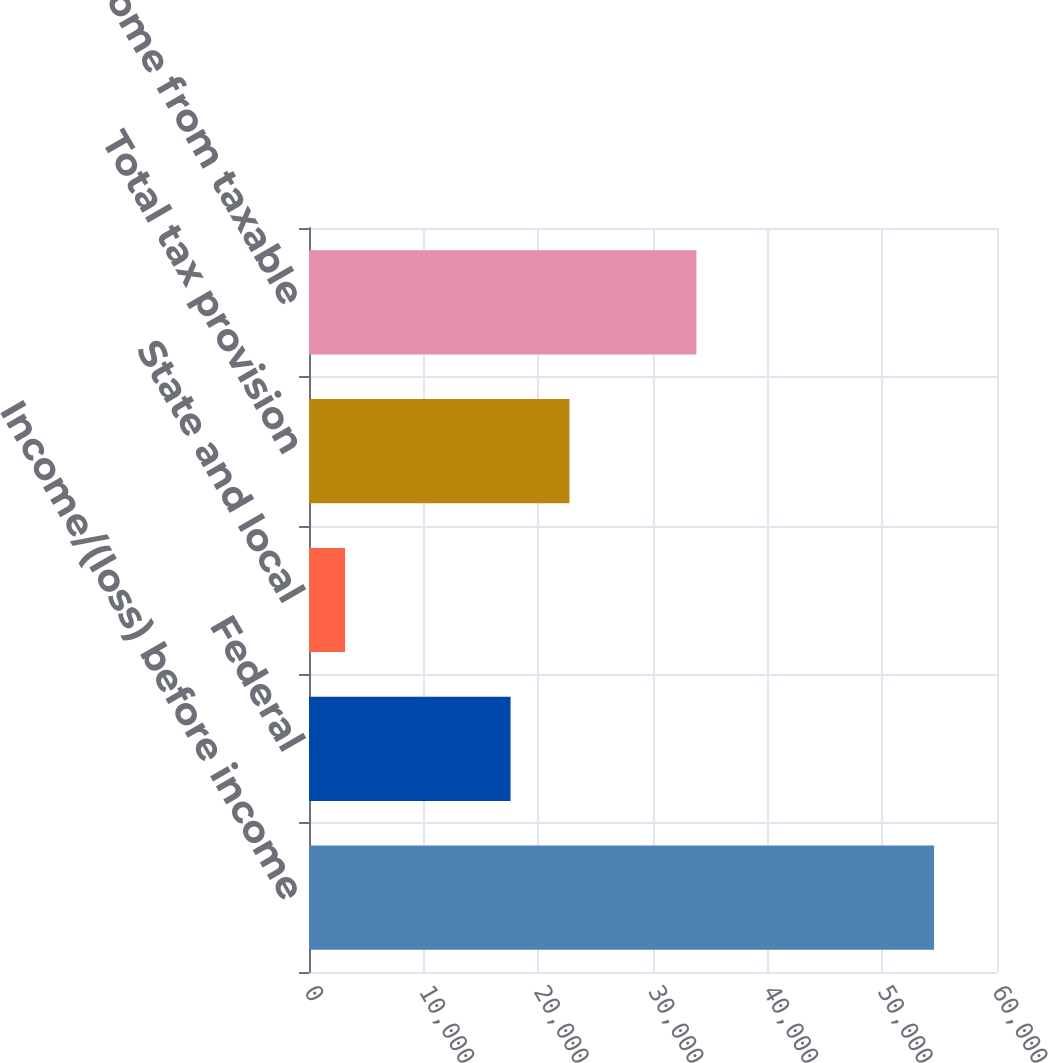<chart> <loc_0><loc_0><loc_500><loc_500><bar_chart><fcel>Income/(loss) before income<fcel>Federal<fcel>State and local<fcel>Total tax provision<fcel>GAAP net income from taxable<nl><fcel>54522<fcel>17581<fcel>3146<fcel>22718.6<fcel>33795<nl></chart> 